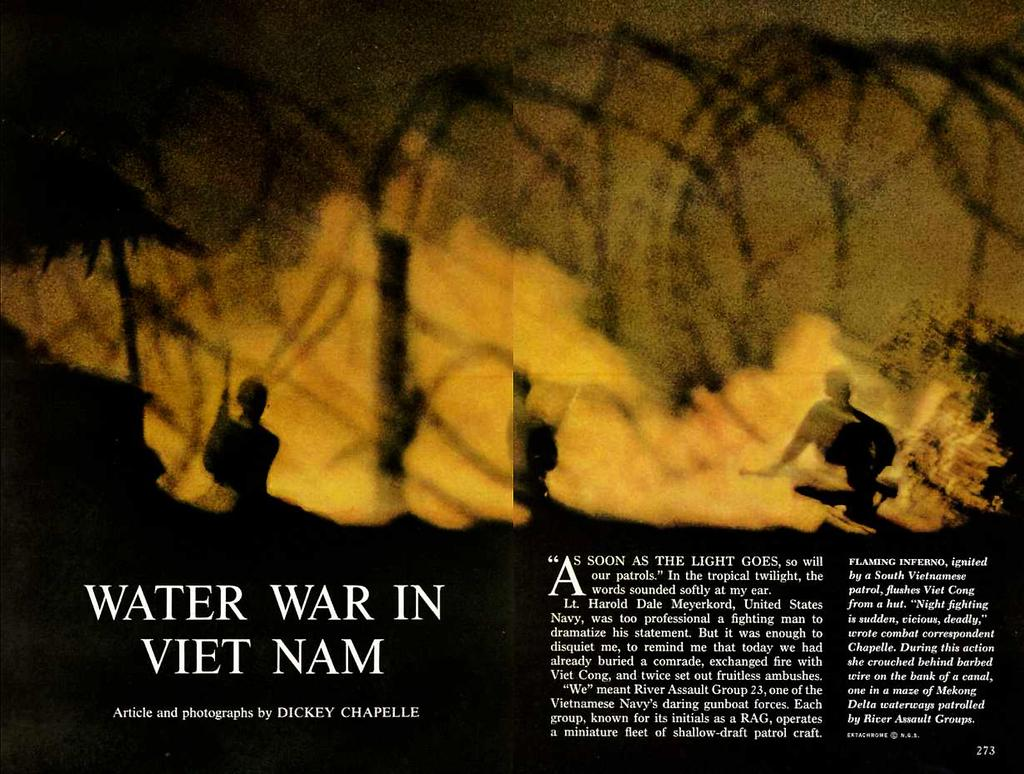<image>
Describe the image concisely. A magazine article titled Water War in Viet Nam. 